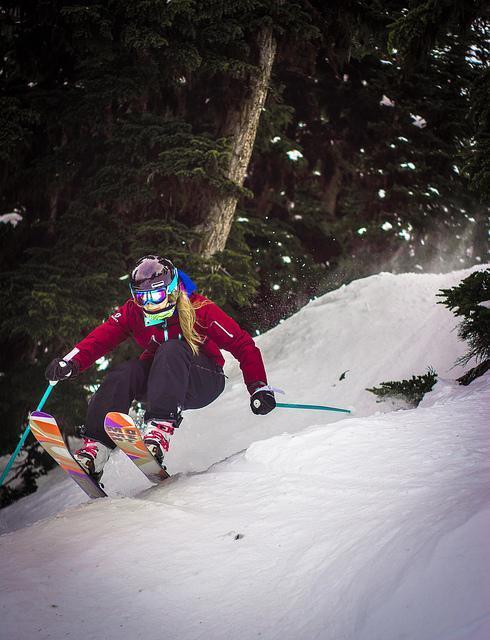How many cats are pictured?
Give a very brief answer. 0. 